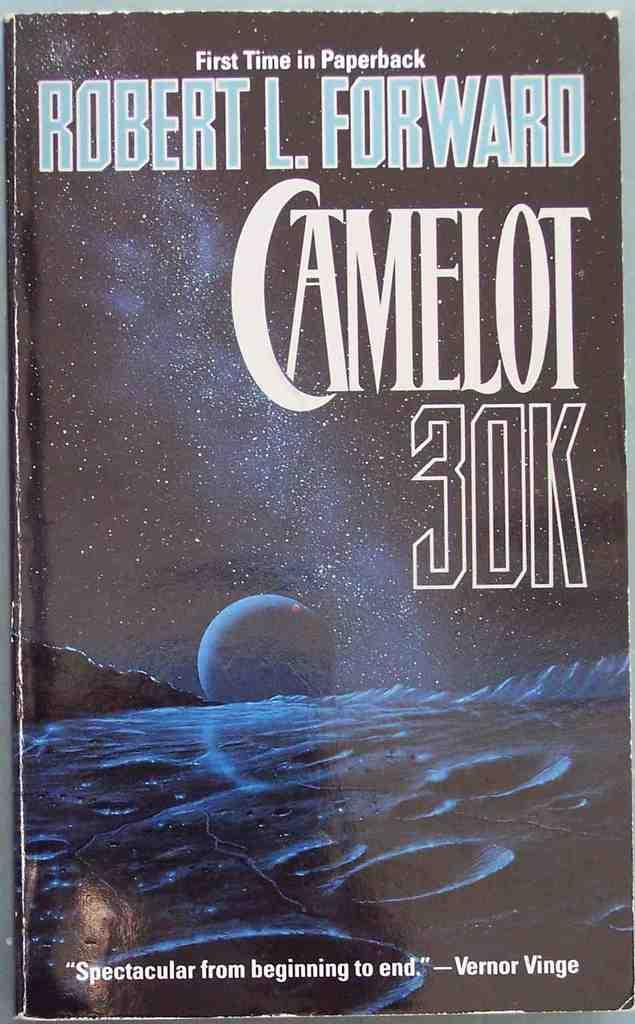<image>
Write a terse but informative summary of the picture. Vernor Vinge has written that Camelot 30K is spectacular from beginning to end. 